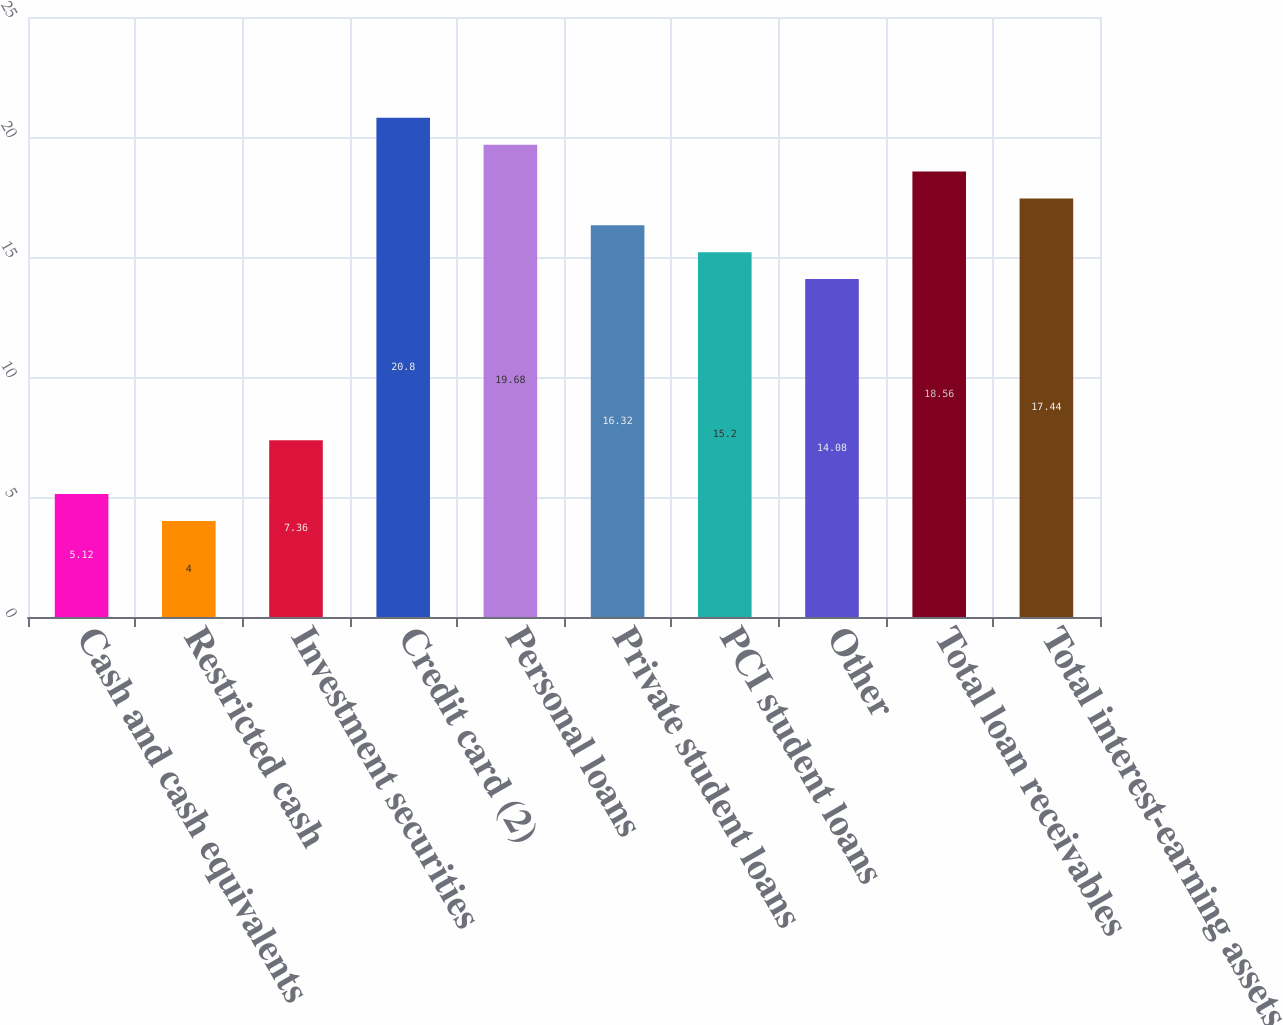Convert chart to OTSL. <chart><loc_0><loc_0><loc_500><loc_500><bar_chart><fcel>Cash and cash equivalents<fcel>Restricted cash<fcel>Investment securities<fcel>Credit card (2)<fcel>Personal loans<fcel>Private student loans<fcel>PCI student loans<fcel>Other<fcel>Total loan receivables<fcel>Total interest-earning assets<nl><fcel>5.12<fcel>4<fcel>7.36<fcel>20.8<fcel>19.68<fcel>16.32<fcel>15.2<fcel>14.08<fcel>18.56<fcel>17.44<nl></chart> 